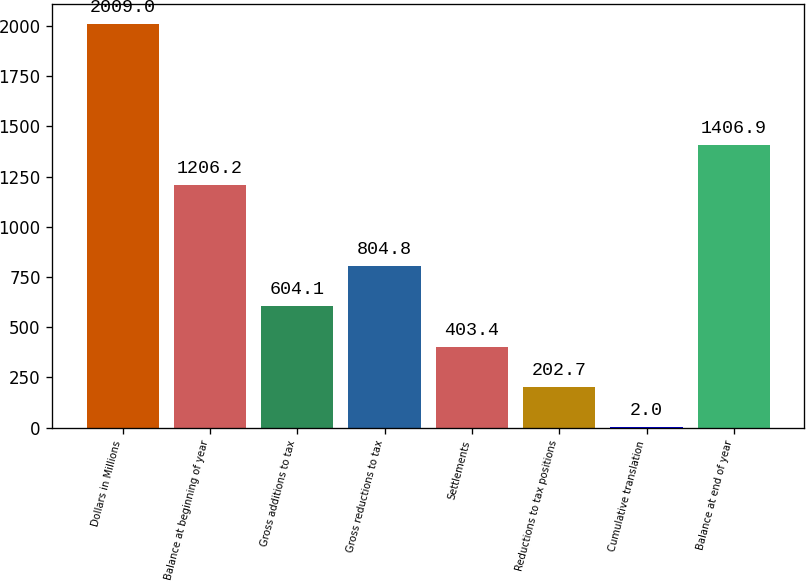Convert chart to OTSL. <chart><loc_0><loc_0><loc_500><loc_500><bar_chart><fcel>Dollars in Millions<fcel>Balance at beginning of year<fcel>Gross additions to tax<fcel>Gross reductions to tax<fcel>Settlements<fcel>Reductions to tax positions<fcel>Cumulative translation<fcel>Balance at end of year<nl><fcel>2009<fcel>1206.2<fcel>604.1<fcel>804.8<fcel>403.4<fcel>202.7<fcel>2<fcel>1406.9<nl></chart> 